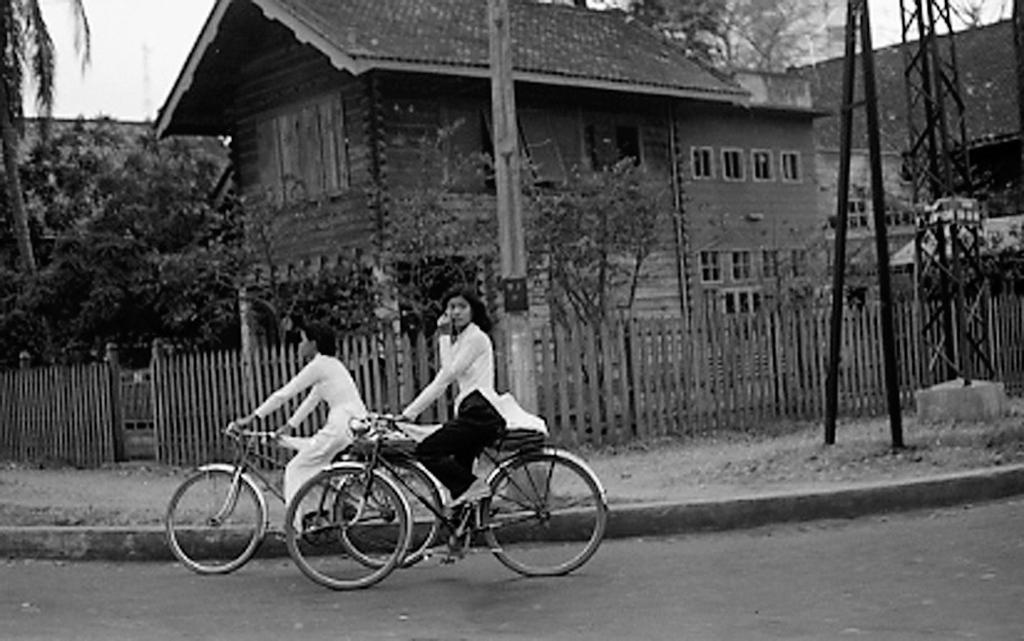Describe this image in one or two sentences. In the picture we can see two women are riding a bicycles just behind, in the background we can find some houses, sky, trees, plants, pole and stand. 